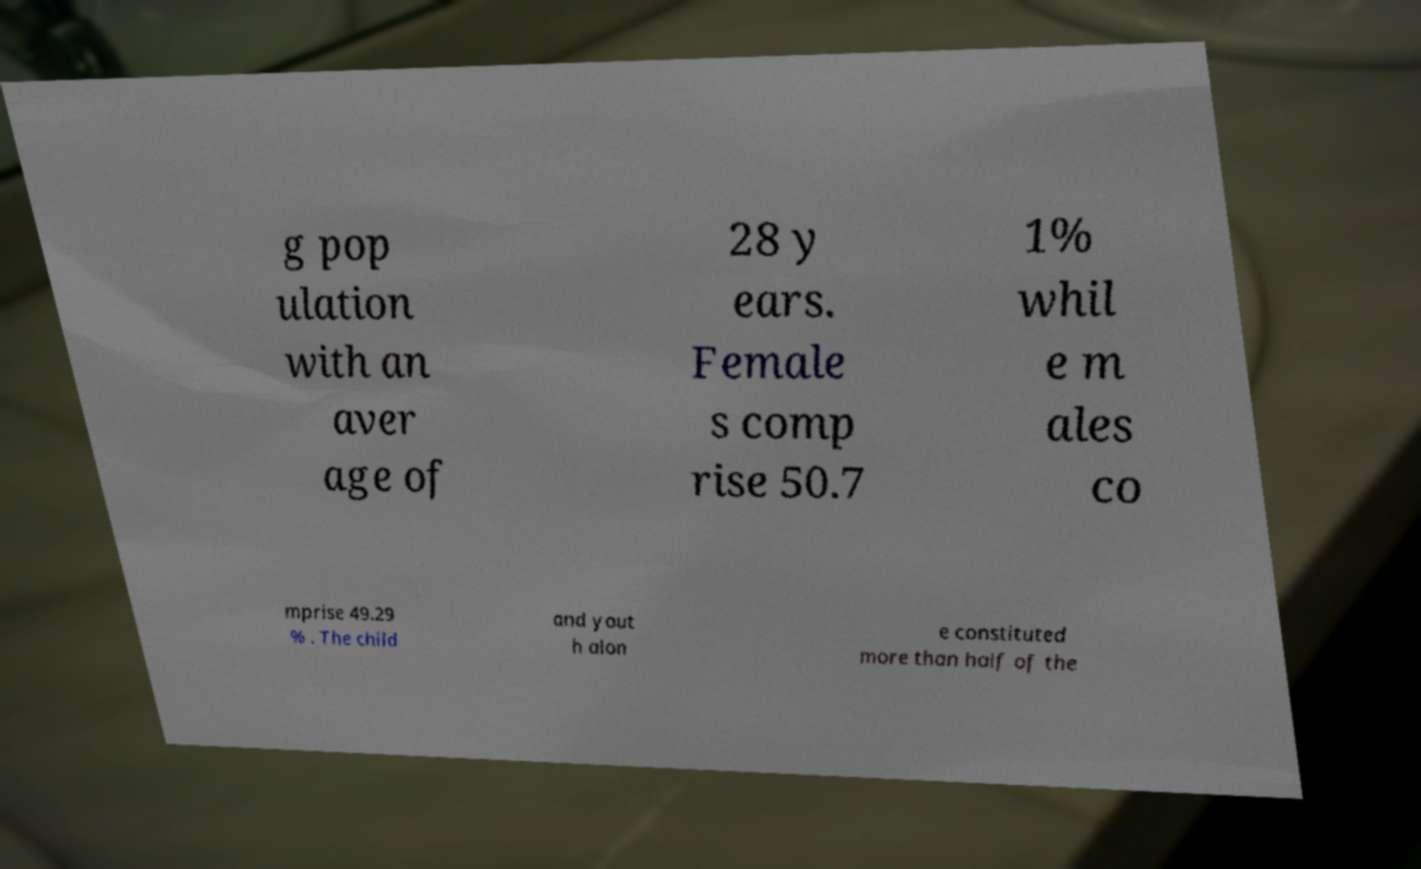What messages or text are displayed in this image? I need them in a readable, typed format. g pop ulation with an aver age of 28 y ears. Female s comp rise 50.7 1% whil e m ales co mprise 49.29 % . The child and yout h alon e constituted more than half of the 